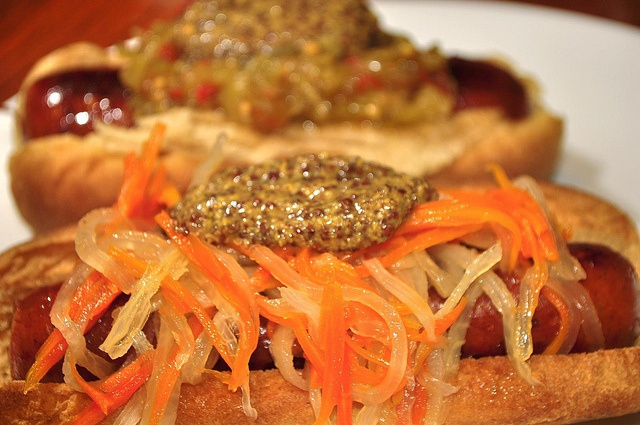Describe the objects in this image and their specific colors. I can see hot dog in maroon, red, brown, and orange tones, carrot in maroon, red, orange, and brown tones, and hot dog in maroon, brown, and orange tones in this image. 